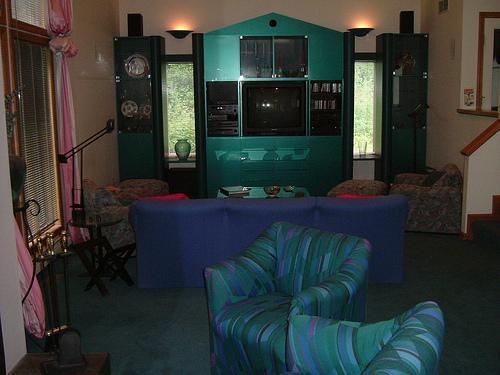How many sofas?
Give a very brief answer. 1. 